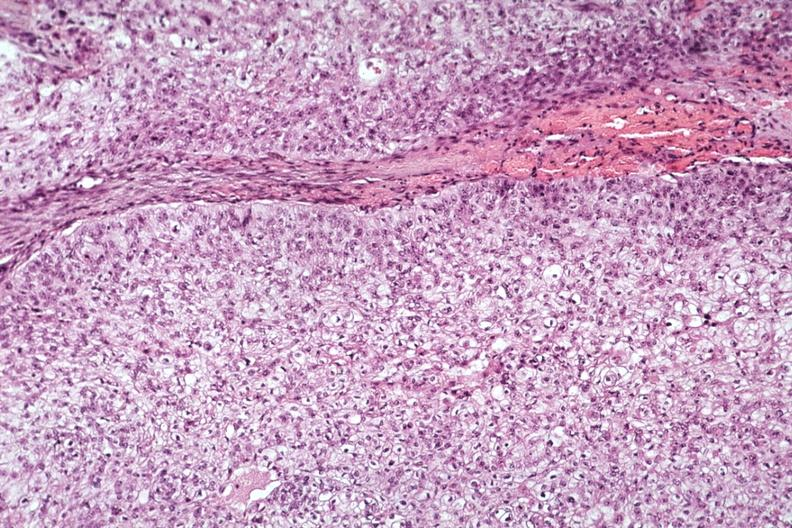s capillary present?
Answer the question using a single word or phrase. No 